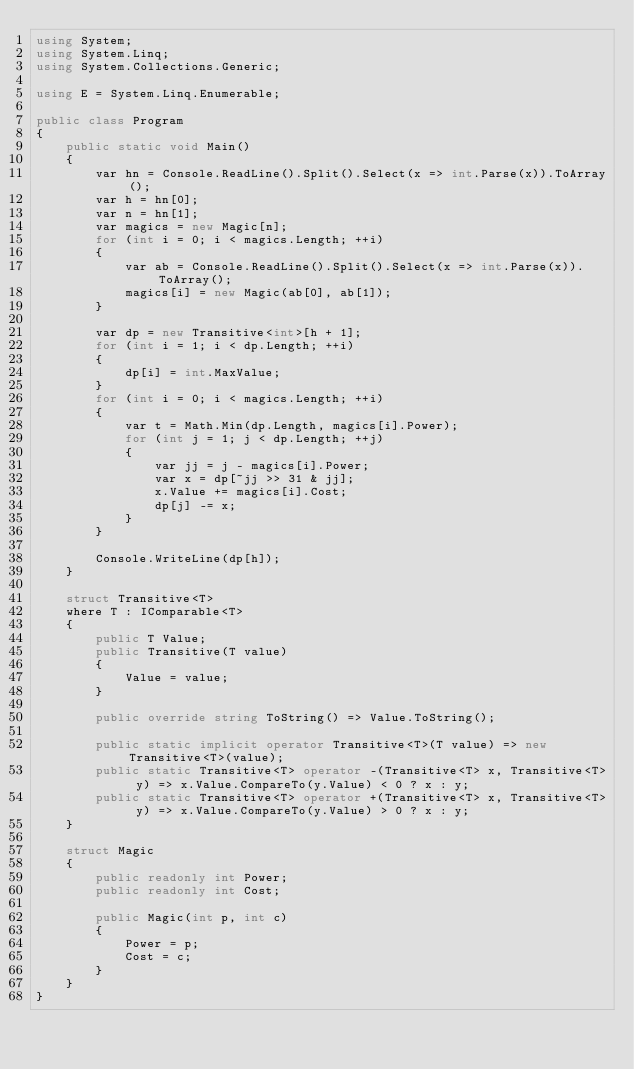Convert code to text. <code><loc_0><loc_0><loc_500><loc_500><_C#_>using System;
using System.Linq;
using System.Collections.Generic;

using E = System.Linq.Enumerable;

public class Program
{
    public static void Main()
    {
        var hn = Console.ReadLine().Split().Select(x => int.Parse(x)).ToArray();
        var h = hn[0];
        var n = hn[1];
        var magics = new Magic[n];
        for (int i = 0; i < magics.Length; ++i)
        {
            var ab = Console.ReadLine().Split().Select(x => int.Parse(x)).ToArray();
            magics[i] = new Magic(ab[0], ab[1]);
        }

        var dp = new Transitive<int>[h + 1];
        for (int i = 1; i < dp.Length; ++i)
        {
            dp[i] = int.MaxValue;
        }
        for (int i = 0; i < magics.Length; ++i)
        {
            var t = Math.Min(dp.Length, magics[i].Power);
            for (int j = 1; j < dp.Length; ++j)
            {
                var jj = j - magics[i].Power;
                var x = dp[~jj >> 31 & jj];
                x.Value += magics[i].Cost;
                dp[j] -= x;
            }
        }

        Console.WriteLine(dp[h]);
    }

    struct Transitive<T>
    where T : IComparable<T>
    {
        public T Value;
        public Transitive(T value)
        {
            Value = value;
        }

        public override string ToString() => Value.ToString();

        public static implicit operator Transitive<T>(T value) => new Transitive<T>(value);
        public static Transitive<T> operator -(Transitive<T> x, Transitive<T> y) => x.Value.CompareTo(y.Value) < 0 ? x : y;
        public static Transitive<T> operator +(Transitive<T> x, Transitive<T> y) => x.Value.CompareTo(y.Value) > 0 ? x : y;
    }

    struct Magic
    {
        public readonly int Power;
        public readonly int Cost;

        public Magic(int p, int c)
        {
            Power = p;
            Cost = c;
        }
    }
}
</code> 